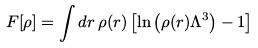Convert formula to latex. <formula><loc_0><loc_0><loc_500><loc_500>F [ \rho ] = \int d r \, \rho ( { r } ) \left [ \ln \left ( \rho ( { r } ) \Lambda ^ { 3 } \right ) - 1 \right ]</formula> 